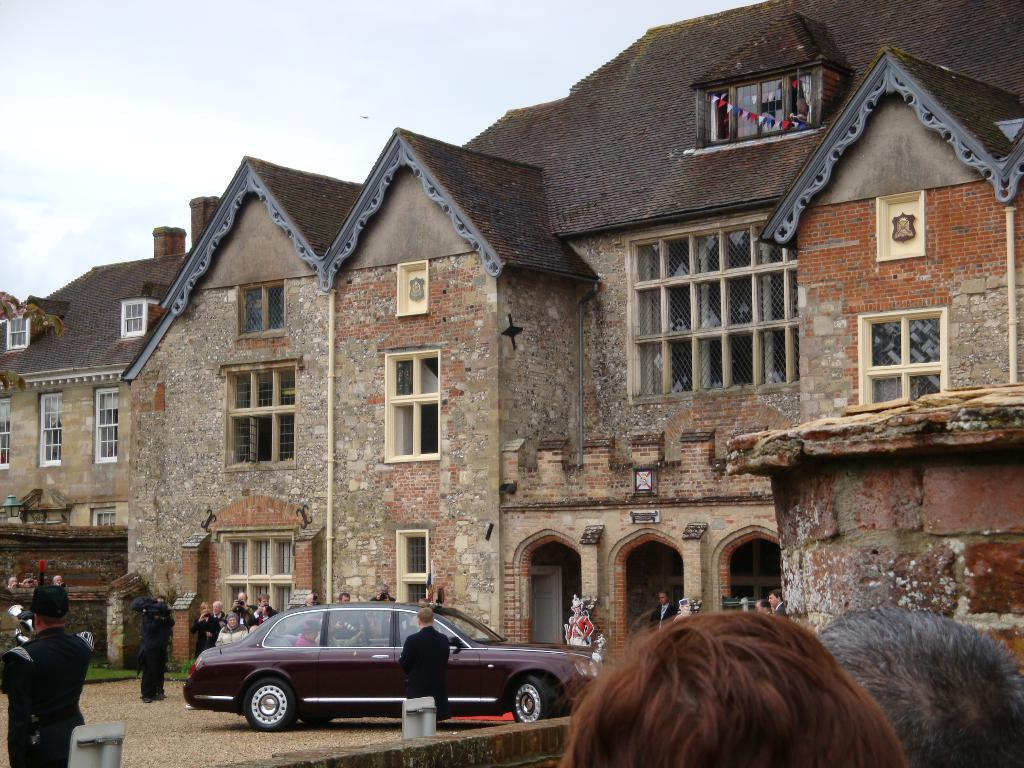What type of structures are present in the image? There are buildings with doors and windows in the image. What mode of transportation can be seen in the image? There is a car in the image. Are there any living beings visible in the image? Yes, there are people visible in the image. What is visible at the top of the image? The sky is visible at the top of the image. Where is the crook hiding in the image? There is no crook present in the image. What type of oven is being used to cook the pan in the image? There is no oven or pan present in the image. 